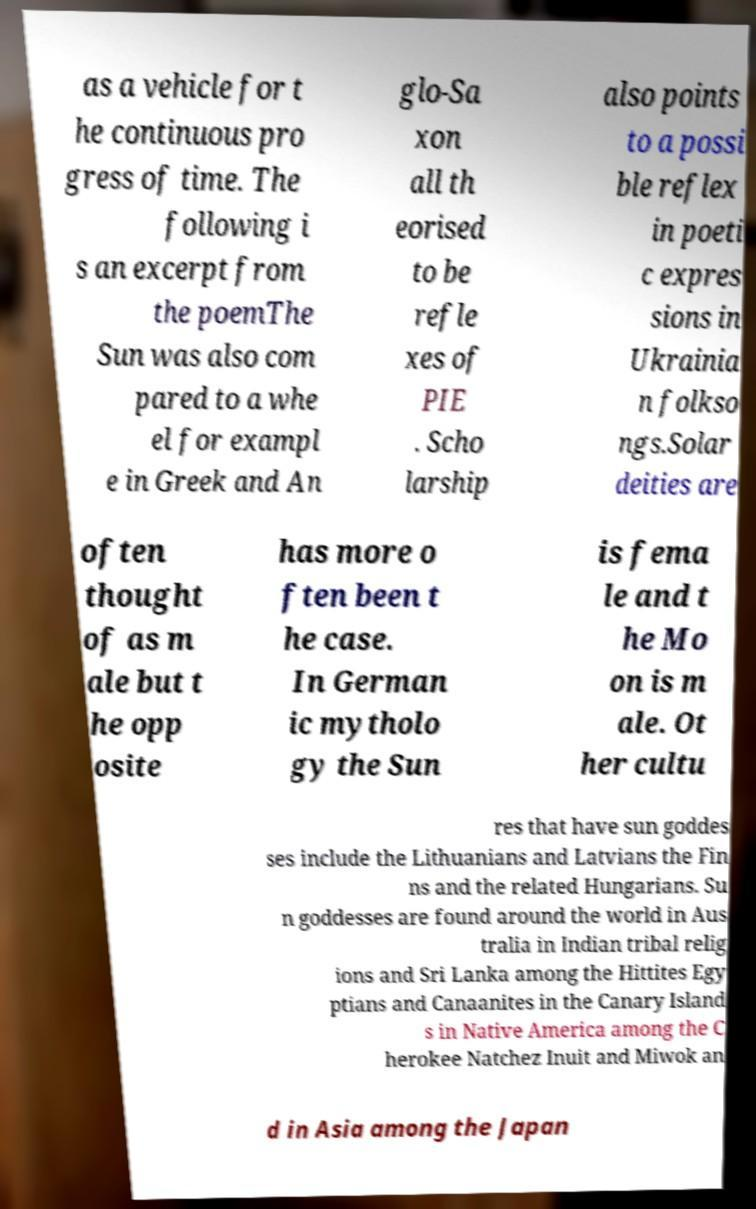Can you accurately transcribe the text from the provided image for me? as a vehicle for t he continuous pro gress of time. The following i s an excerpt from the poemThe Sun was also com pared to a whe el for exampl e in Greek and An glo-Sa xon all th eorised to be refle xes of PIE . Scho larship also points to a possi ble reflex in poeti c expres sions in Ukrainia n folkso ngs.Solar deities are often thought of as m ale but t he opp osite has more o ften been t he case. In German ic mytholo gy the Sun is fema le and t he Mo on is m ale. Ot her cultu res that have sun goddes ses include the Lithuanians and Latvians the Fin ns and the related Hungarians. Su n goddesses are found around the world in Aus tralia in Indian tribal relig ions and Sri Lanka among the Hittites Egy ptians and Canaanites in the Canary Island s in Native America among the C herokee Natchez Inuit and Miwok an d in Asia among the Japan 